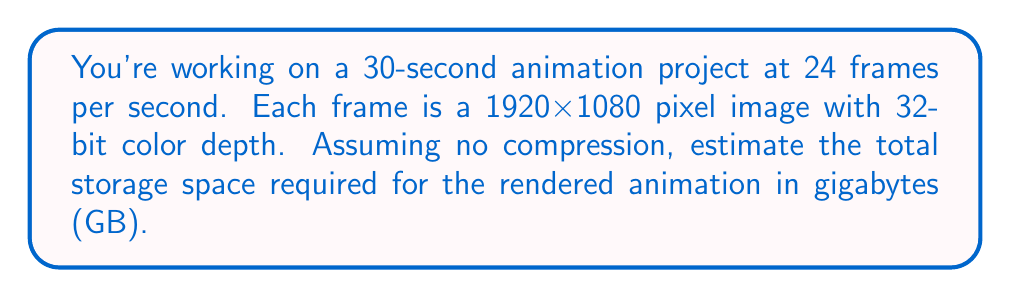Show me your answer to this math problem. Let's break this down step-by-step:

1. Calculate the number of frames:
   $$ \text{Total frames} = 30 \text{ seconds} \times 24 \text{ frames/second} = 720 \text{ frames} $$

2. Calculate the number of pixels per frame:
   $$ \text{Pixels per frame} = 1920 \times 1080 = 2,073,600 \text{ pixels} $$

3. Calculate the number of bits per frame:
   $$ \text{Bits per frame} = 2,073,600 \text{ pixels} \times 32 \text{ bits/pixel} = 66,355,200 \text{ bits} $$

4. Convert bits to bytes:
   $$ \text{Bytes per frame} = 66,355,200 \text{ bits} \div 8 \text{ bits/byte} = 8,294,400 \text{ bytes} $$

5. Calculate total bytes for all frames:
   $$ \text{Total bytes} = 8,294,400 \text{ bytes/frame} \times 720 \text{ frames} = 5,971,968,000 \text{ bytes} $$

6. Convert bytes to gigabytes:
   $$ \text{Gigabytes} = 5,971,968,000 \text{ bytes} \div (1024^3 \text{ bytes/GB}) \approx 5.56 \text{ GB} $$
Answer: 5.56 GB 